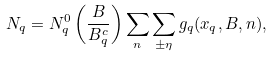<formula> <loc_0><loc_0><loc_500><loc_500>N _ { q } = N ^ { 0 } _ { q } \left ( \frac { B } { B ^ { c } _ { q } } \right ) \sum _ { n } \sum _ { \pm \eta } g _ { q } ( x _ { q } , B , n ) ,</formula> 